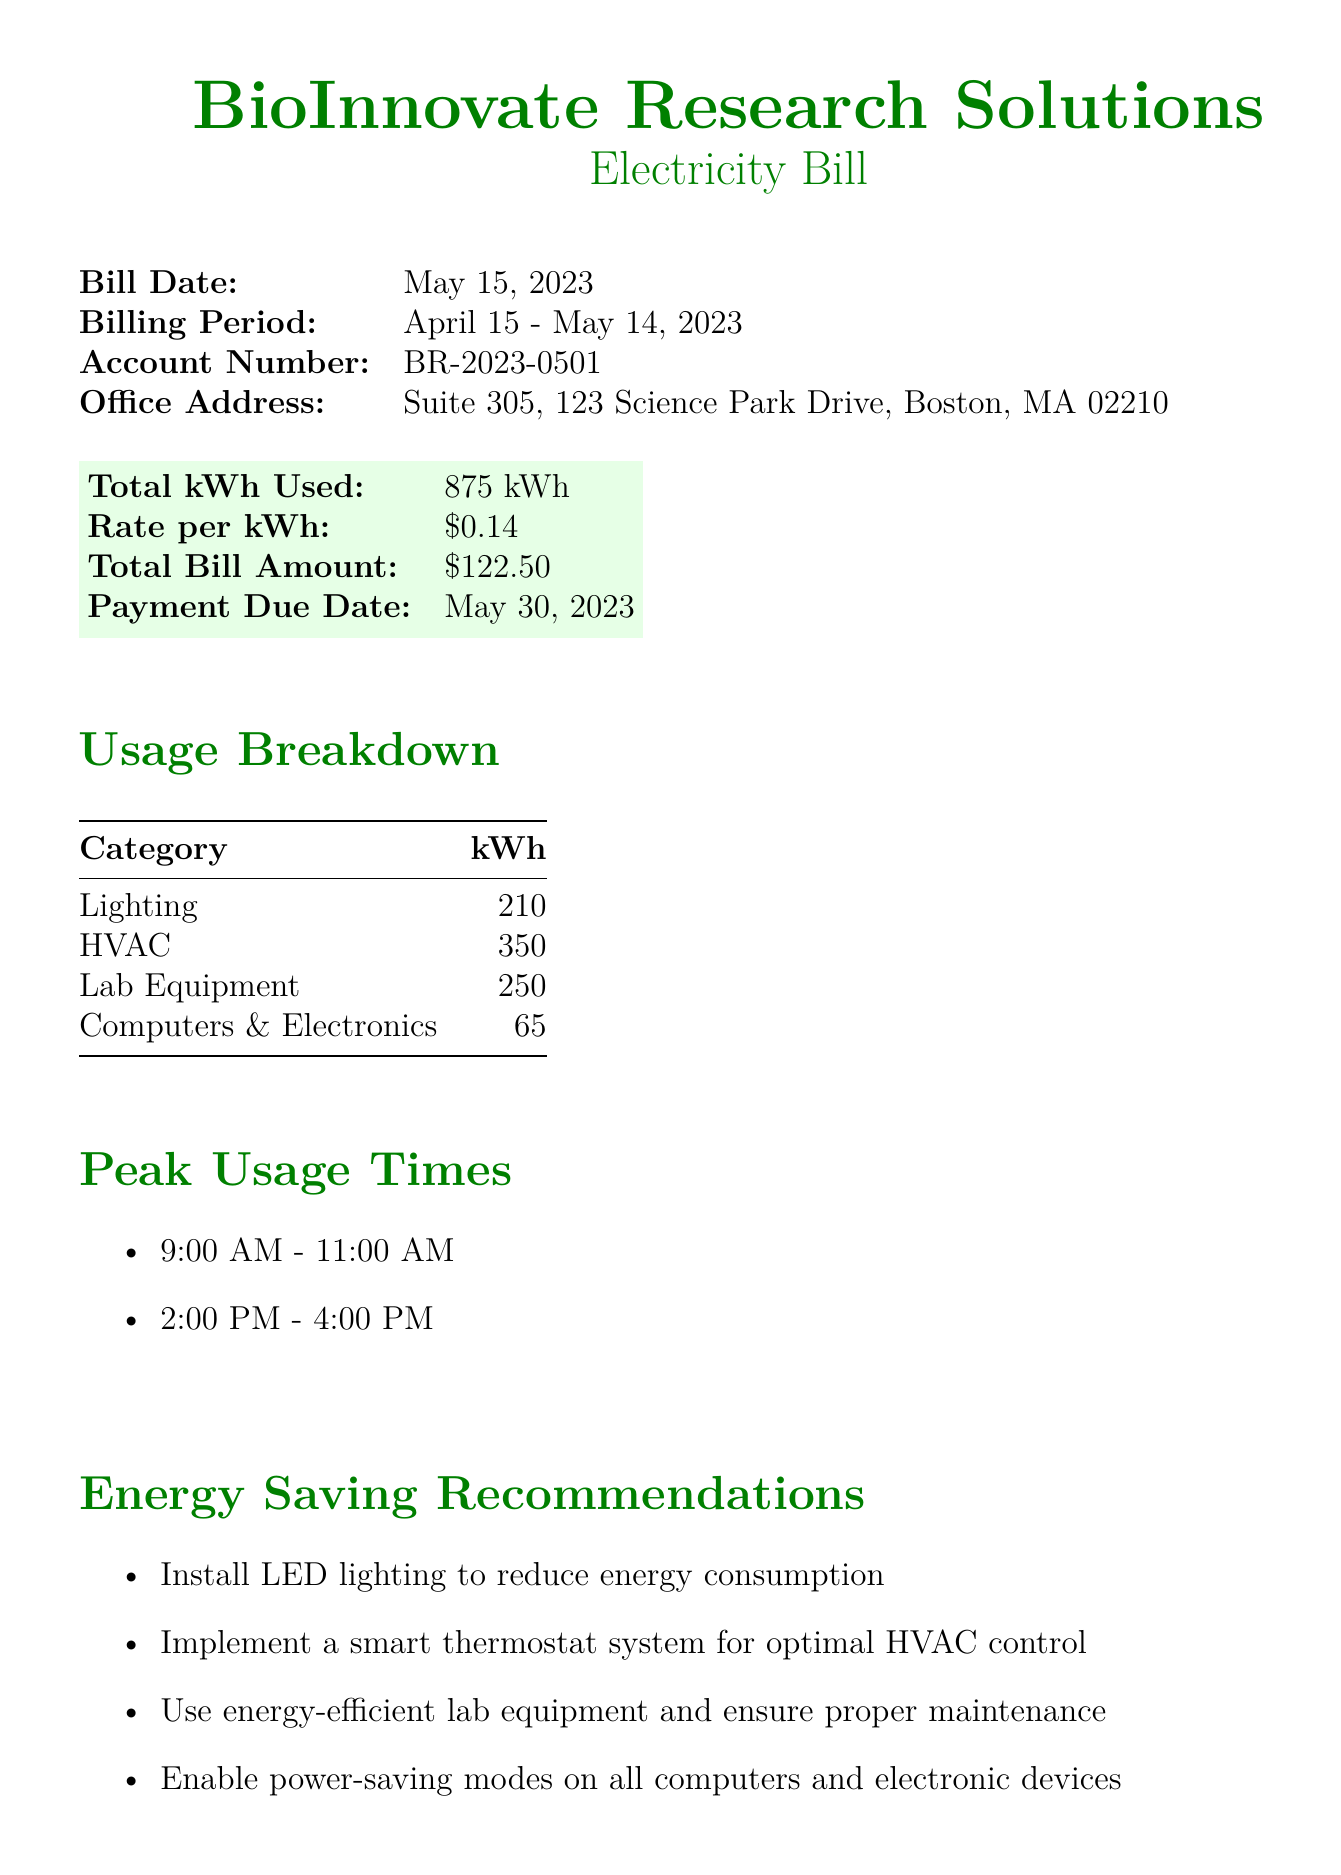What is the bill date? The bill date is specified in the document and is May 15, 2023.
Answer: May 15, 2023 What is the total kWh used? The document states the total kWh used is 875 kWh.
Answer: 875 kWh What is the total bill amount? The total bill amount is provided in the document as \$122.50.
Answer: \$122.50 What time frame is the billing period? The billing period is detailed and lasts from April 15 to May 14, 2023.
Answer: April 15 - May 14, 2023 What is the recommended action for HVAC control? The document recommends implementing a smart thermostat system for optimal HVAC control.
Answer: Smart thermostat system What was the percentage change in usage compared to the previous month? The change in usage is noted as +5% compared to the previous month.
Answer: +5% During what hours is peak usage noted? The document lists peak usage times as 9:00 AM - 11:00 AM and 2:00 PM - 4:00 PM.
Answer: 9:00 AM - 11:00 AM and 2:00 PM - 4:00 PM What type of lighting is recommended for energy savings? The document specifically recommends installing LED lighting to reduce energy consumption.
Answer: LED lighting What is the account number for the bill? The account number is given in the document as BR-2023-0501.
Answer: BR-2023-0501 